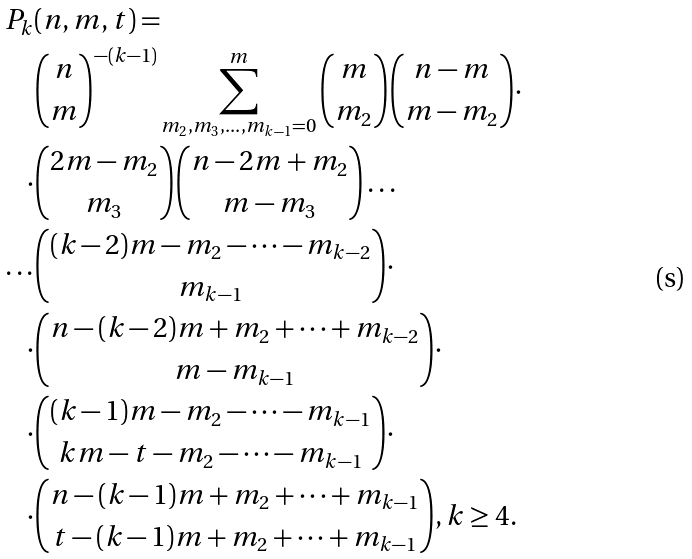Convert formula to latex. <formula><loc_0><loc_0><loc_500><loc_500>P _ { k } & ( n , m , t ) = \\ & \binom { n } { m } ^ { - ( k - 1 ) } \sum _ { m _ { 2 } , m _ { 3 } , \dots , m _ { k - 1 } = 0 } ^ { m } \binom { m } { m _ { 2 } } \binom { n - m } { m - m _ { 2 } } \cdot \\ \cdot & \binom { 2 m - m _ { 2 } } { m _ { 3 } } \binom { n - 2 m + m _ { 2 } } { m - m _ { 3 } } \dots \\ \dots & \binom { ( k - 2 ) m - m _ { 2 } - \dots - m _ { k - 2 } } { m _ { k - 1 } } \cdot \\ \cdot & \binom { n - ( k - 2 ) m + m _ { 2 } + \dots + m _ { k - 2 } } { m - m _ { k - 1 } } \cdot \\ \cdot & \binom { ( k - 1 ) m - m _ { 2 } - \dots - m _ { k - 1 } } { k m - t - m _ { 2 } - \dots - m _ { k - 1 } } \cdot \\ \cdot & \binom { n - ( k - 1 ) m + m _ { 2 } + \dots + m _ { k - 1 } } { t - ( k - 1 ) m + m _ { 2 } + \dots + m _ { k - 1 } } , k \geq 4 .</formula> 